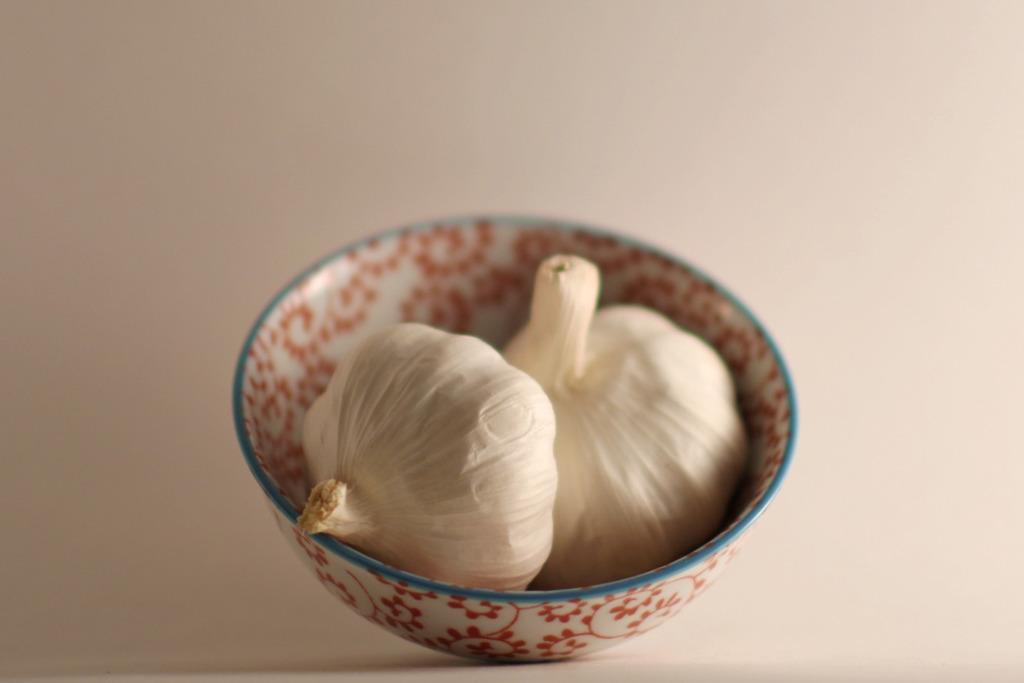How would you summarize this image in a sentence or two? In this image, I can see two garlic in a bowl. The background looks white in color. 